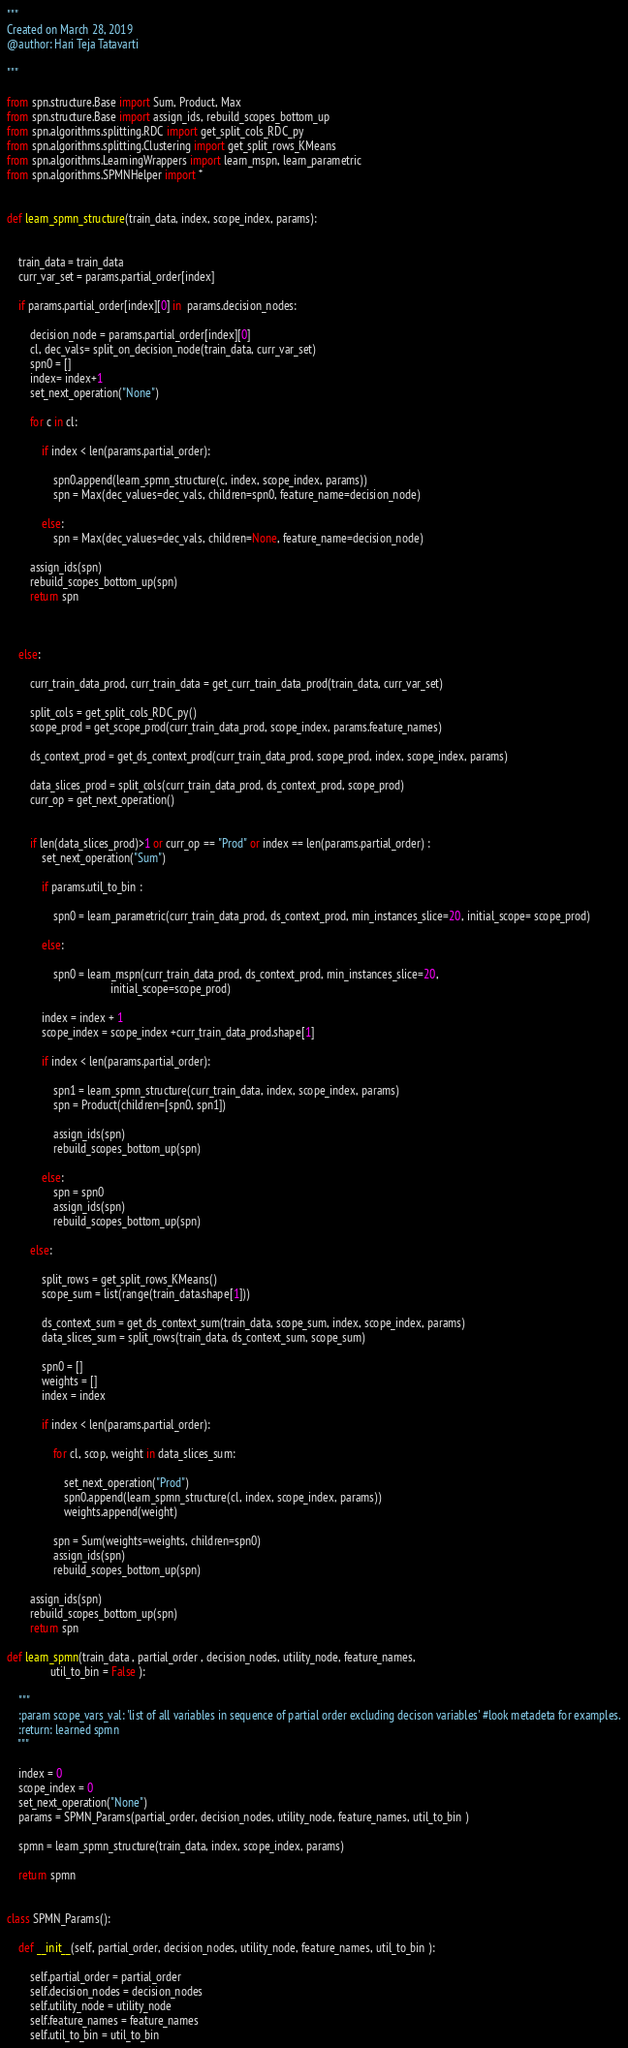<code> <loc_0><loc_0><loc_500><loc_500><_Python_>"""
Created on March 28, 2019
@author: Hari Teja Tatavarti

"""

from spn.structure.Base import Sum, Product, Max
from spn.structure.Base import assign_ids, rebuild_scopes_bottom_up
from spn.algorithms.splitting.RDC import get_split_cols_RDC_py
from spn.algorithms.splitting.Clustering import get_split_rows_KMeans
from spn.algorithms.LearningWrappers import learn_mspn, learn_parametric
from spn.algorithms.SPMNHelper import *


def learn_spmn_structure(train_data, index, scope_index, params):


    train_data = train_data
    curr_var_set = params.partial_order[index]

    if params.partial_order[index][0] in  params.decision_nodes:

        decision_node = params.partial_order[index][0]
        cl, dec_vals= split_on_decision_node(train_data, curr_var_set)
        spn0 = []
        index= index+1
        set_next_operation("None")

        for c in cl:

            if index < len(params.partial_order):

                spn0.append(learn_spmn_structure(c, index, scope_index, params))
                spn = Max(dec_values=dec_vals, children=spn0, feature_name=decision_node)

            else:
                spn = Max(dec_values=dec_vals, children=None, feature_name=decision_node)

        assign_ids(spn)
        rebuild_scopes_bottom_up(spn)
        return spn



    else:

        curr_train_data_prod, curr_train_data = get_curr_train_data_prod(train_data, curr_var_set)

        split_cols = get_split_cols_RDC_py()
        scope_prod = get_scope_prod(curr_train_data_prod, scope_index, params.feature_names)

        ds_context_prod = get_ds_context_prod(curr_train_data_prod, scope_prod, index, scope_index, params)

        data_slices_prod = split_cols(curr_train_data_prod, ds_context_prod, scope_prod)
        curr_op = get_next_operation()


        if len(data_slices_prod)>1 or curr_op == "Prod" or index == len(params.partial_order) :
            set_next_operation("Sum")

            if params.util_to_bin :

                spn0 = learn_parametric(curr_train_data_prod, ds_context_prod, min_instances_slice=20, initial_scope= scope_prod)

            else:

                spn0 = learn_mspn(curr_train_data_prod, ds_context_prod, min_instances_slice=20,
                                    initial_scope=scope_prod)

            index = index + 1
            scope_index = scope_index +curr_train_data_prod.shape[1]

            if index < len(params.partial_order):

                spn1 = learn_spmn_structure(curr_train_data, index, scope_index, params)
                spn = Product(children=[spn0, spn1])

                assign_ids(spn)
                rebuild_scopes_bottom_up(spn)

            else:
                spn = spn0
                assign_ids(spn)
                rebuild_scopes_bottom_up(spn)

        else:

            split_rows = get_split_rows_KMeans()
            scope_sum = list(range(train_data.shape[1]))

            ds_context_sum = get_ds_context_sum(train_data, scope_sum, index, scope_index, params)
            data_slices_sum = split_rows(train_data, ds_context_sum, scope_sum)

            spn0 = []
            weights = []
            index = index

            if index < len(params.partial_order):

                for cl, scop, weight in data_slices_sum:

                    set_next_operation("Prod")
                    spn0.append(learn_spmn_structure(cl, index, scope_index, params))
                    weights.append(weight)

                spn = Sum(weights=weights, children=spn0)
                assign_ids(spn)
                rebuild_scopes_bottom_up(spn)

        assign_ids(spn)
        rebuild_scopes_bottom_up(spn)
        return spn

def learn_spmn(train_data , partial_order , decision_nodes, utility_node, feature_names,
               util_to_bin = False ):

    """
    :param scope_vars_val: 'list of all variables in sequence of partial order excluding decison variables' #look metadeta for examples.
    :return: learned spmn
    """

    index = 0
    scope_index = 0
    set_next_operation("None")
    params = SPMN_Params(partial_order, decision_nodes, utility_node, feature_names, util_to_bin )

    spmn = learn_spmn_structure(train_data, index, scope_index, params)

    return spmn


class SPMN_Params():

    def __init__(self, partial_order, decision_nodes, utility_node, feature_names, util_to_bin ):

        self.partial_order = partial_order
        self.decision_nodes = decision_nodes
        self.utility_node = utility_node
        self.feature_names = feature_names
        self.util_to_bin = util_to_bin



























</code> 